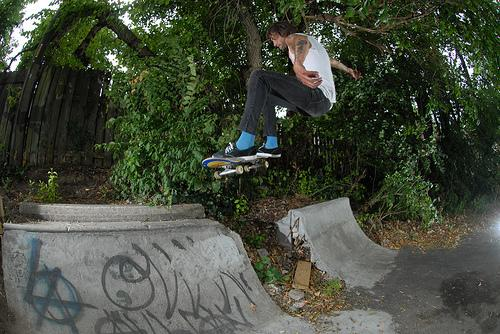How many bushes can be seen in the image and what part of the plant is visible? Two bushes are visible in the image, showing their leaves. What kind of shirt is the man wearing and what is its color? The man is wearing a white tank top. What type of object is visible in the background and what is it made of? A wooden fence is visible in the background of the image. List all objects placed on or around the ramp. Graffiti, dried leaves, a bush, a wooden fence, a piece of wood, and dirty pavement surround the ramp. Describe the man's footwear in detail. The man is wearing black shoes with bright blue socks on both feet. Mention a piece of protective gear the man is not wearing while skateboarding. The man is not wearing any helmet or knee pads while performing his trick. What is the color combination of the skateboard and can you identify its wheels? The skateboard is blue and yellow, and its wheels can be seen in the image. What items does the man have on him while performing a skateboard trick? The man has a skateboard, black jeans, a white tank top, blue socks, black shoes, and a forearm tattoo. What is the state of the ramp and what has been done to it? The ramp is dirty and covered in graffiti. Use one sentence to describe the appearance and action of the man in the image. A long-haired man with a forearm tattoo is riding a blue and yellow skateboard in the air, performing a trick without protective gear. Is the skateboarder jumping over a puddle of water? There is no mention of a puddle of water in the image annotations. The skateboarder is described as being in the air and performing a trick, but not specifically jumping over a puddle. Is the skateboarder wearing a helmet? None of the annotations mention a helmet. The only clothing items and accessories mentioned are socks, pants, a tank top, and shoes. Are there any birds sitting on the wooden fence in the background? There is a mention of a wooden fence in the background, but no birds are mentioned in any of the image annotations. Can you spot the red ball in the scene? There is no mention of a red ball in any of the annotations. All objects are related to a skateboarder, his clothes, and the ramp he's on. Is the person holding an umbrella in his hand? There is no mention of an umbrella in the image annotations, as all objects listed are related to the skateboarder and his surroundings, not an umbrella. Can you see a dog running alongside the skateboarder? There is no mention of a dog in any of the image annotations. All objects described are either part of the skateboarder or his surroundings, not a dog. 